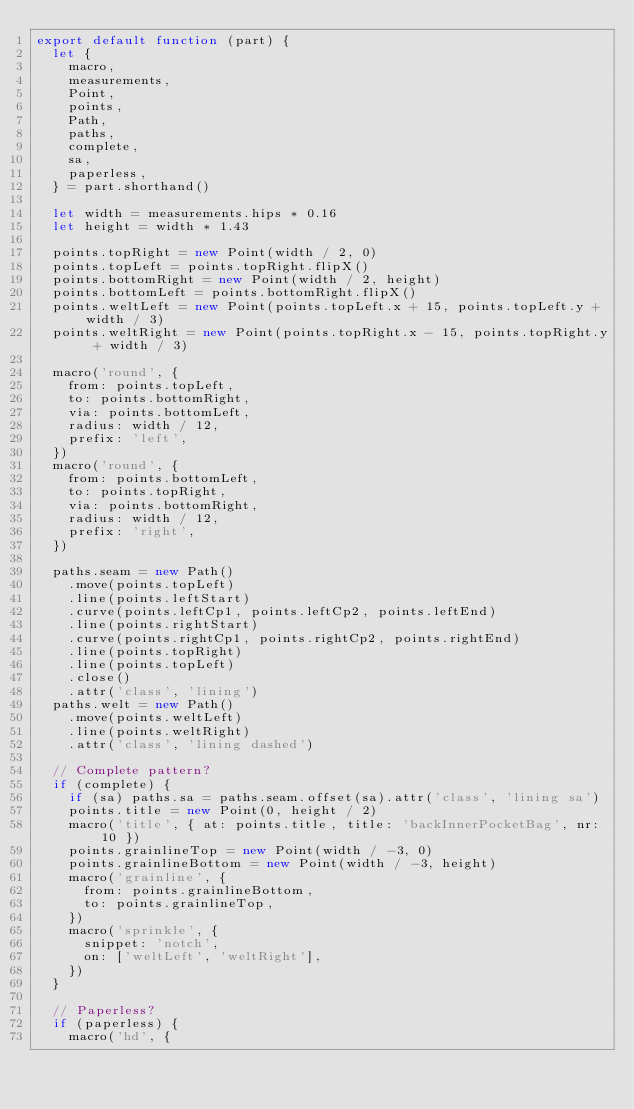<code> <loc_0><loc_0><loc_500><loc_500><_JavaScript_>export default function (part) {
  let {
    macro,
    measurements,
    Point,
    points,
    Path,
    paths,
    complete,
    sa,
    paperless,
  } = part.shorthand()

  let width = measurements.hips * 0.16
  let height = width * 1.43

  points.topRight = new Point(width / 2, 0)
  points.topLeft = points.topRight.flipX()
  points.bottomRight = new Point(width / 2, height)
  points.bottomLeft = points.bottomRight.flipX()
  points.weltLeft = new Point(points.topLeft.x + 15, points.topLeft.y + width / 3)
  points.weltRight = new Point(points.topRight.x - 15, points.topRight.y + width / 3)

  macro('round', {
    from: points.topLeft,
    to: points.bottomRight,
    via: points.bottomLeft,
    radius: width / 12,
    prefix: 'left',
  })
  macro('round', {
    from: points.bottomLeft,
    to: points.topRight,
    via: points.bottomRight,
    radius: width / 12,
    prefix: 'right',
  })

  paths.seam = new Path()
    .move(points.topLeft)
    .line(points.leftStart)
    .curve(points.leftCp1, points.leftCp2, points.leftEnd)
    .line(points.rightStart)
    .curve(points.rightCp1, points.rightCp2, points.rightEnd)
    .line(points.topRight)
    .line(points.topLeft)
    .close()
    .attr('class', 'lining')
  paths.welt = new Path()
    .move(points.weltLeft)
    .line(points.weltRight)
    .attr('class', 'lining dashed')

  // Complete pattern?
  if (complete) {
    if (sa) paths.sa = paths.seam.offset(sa).attr('class', 'lining sa')
    points.title = new Point(0, height / 2)
    macro('title', { at: points.title, title: 'backInnerPocketBag', nr: 10 })
    points.grainlineTop = new Point(width / -3, 0)
    points.grainlineBottom = new Point(width / -3, height)
    macro('grainline', {
      from: points.grainlineBottom,
      to: points.grainlineTop,
    })
    macro('sprinkle', {
      snippet: 'notch',
      on: ['weltLeft', 'weltRight'],
    })
  }

  // Paperless?
  if (paperless) {
    macro('hd', {</code> 